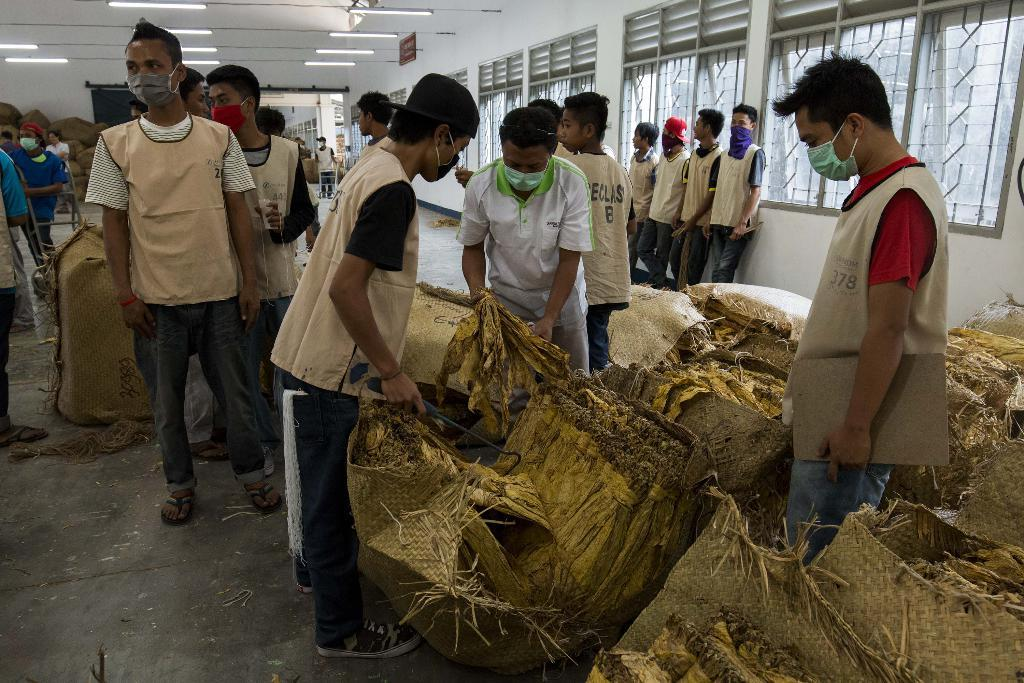What is happening in the image? There are people standing in the image. What can be seen on the floor in the image? There are bags and other objects on the floor in the image. What is visible at the top of the image? There are lights visible at the top of the image. What feature allows natural light to enter the space in the image? There are windows in the image. What is the tendency of the bushes in the image? There are no bushes present in the image. 